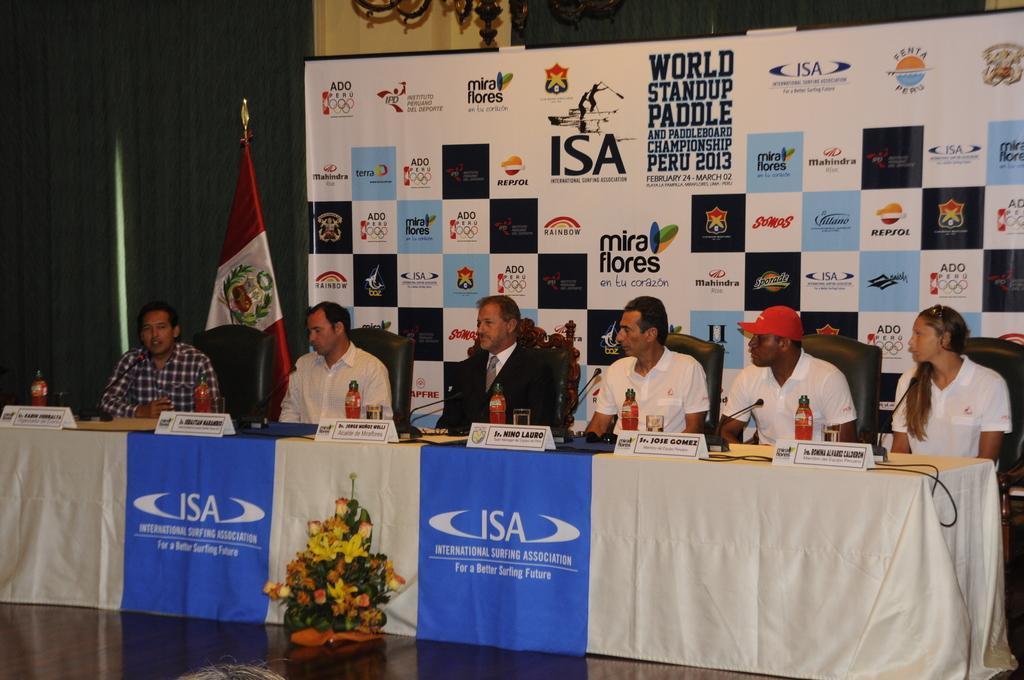Could you give a brief overview of what you see in this image? People are sitting on the chair near the table and above the table there is bottle, in the background there is poster and flag. 